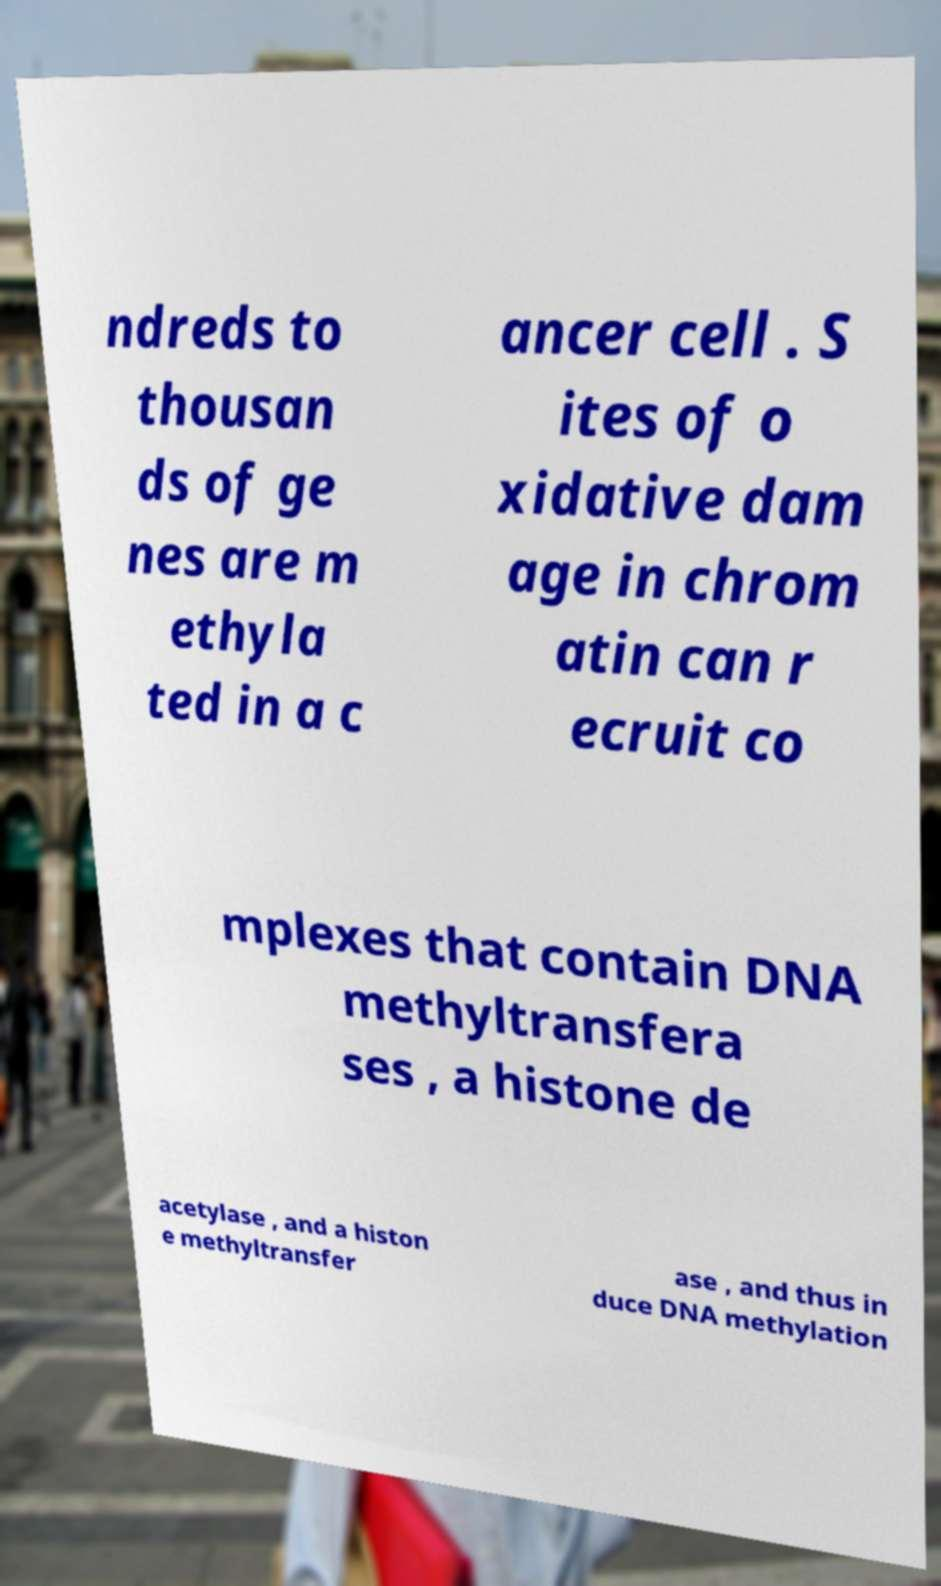What messages or text are displayed in this image? I need them in a readable, typed format. ndreds to thousan ds of ge nes are m ethyla ted in a c ancer cell . S ites of o xidative dam age in chrom atin can r ecruit co mplexes that contain DNA methyltransfera ses , a histone de acetylase , and a histon e methyltransfer ase , and thus in duce DNA methylation 